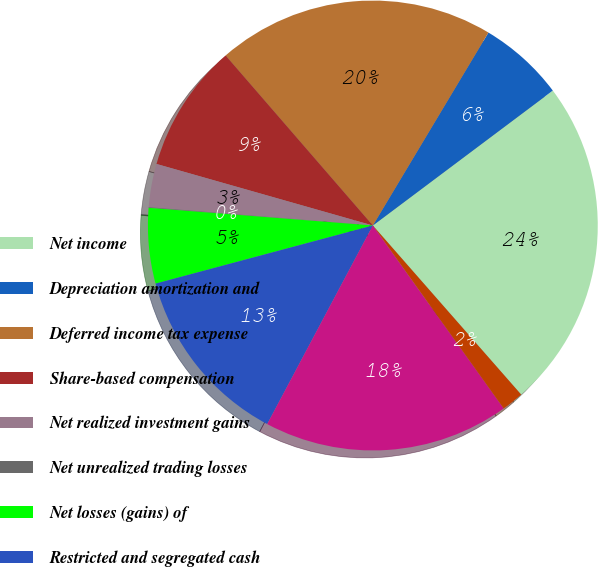<chart> <loc_0><loc_0><loc_500><loc_500><pie_chart><fcel>Net income<fcel>Depreciation amortization and<fcel>Deferred income tax expense<fcel>Share-based compensation<fcel>Net realized investment gains<fcel>Net unrealized trading losses<fcel>Net losses (gains) of<fcel>Restricted and segregated cash<fcel>Deferred acquisition costs<fcel>Other investments net<nl><fcel>23.78%<fcel>6.17%<fcel>19.95%<fcel>9.23%<fcel>3.11%<fcel>0.05%<fcel>5.41%<fcel>13.06%<fcel>17.66%<fcel>1.58%<nl></chart> 